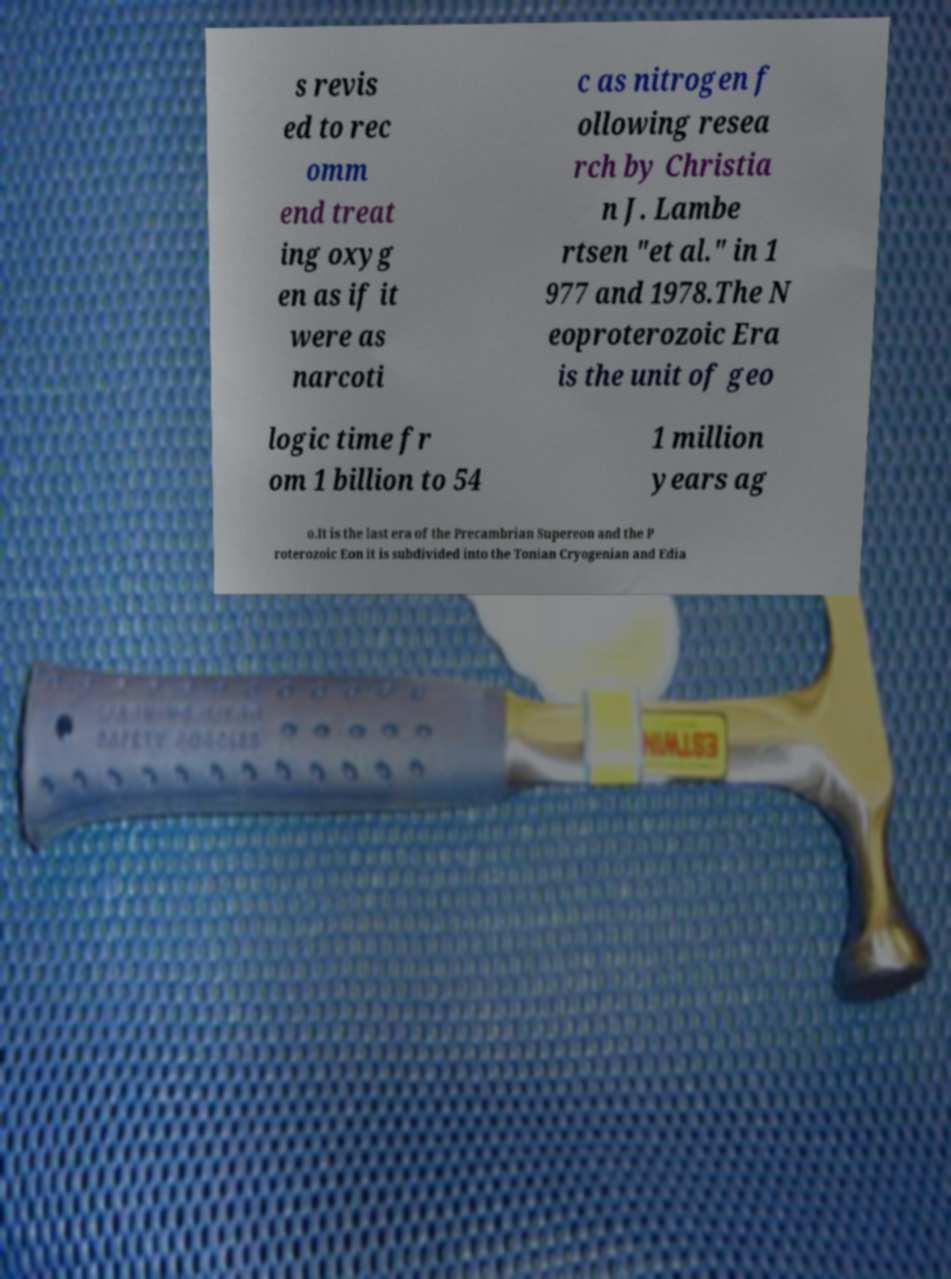I need the written content from this picture converted into text. Can you do that? s revis ed to rec omm end treat ing oxyg en as if it were as narcoti c as nitrogen f ollowing resea rch by Christia n J. Lambe rtsen "et al." in 1 977 and 1978.The N eoproterozoic Era is the unit of geo logic time fr om 1 billion to 54 1 million years ag o.It is the last era of the Precambrian Supereon and the P roterozoic Eon it is subdivided into the Tonian Cryogenian and Edia 